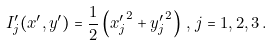<formula> <loc_0><loc_0><loc_500><loc_500>I ^ { \prime } _ { j } ( x ^ { \prime } , y ^ { \prime } ) = \frac { 1 } { 2 } \left ( { x ^ { \prime } _ { j } } ^ { 2 } + { y ^ { \prime } _ { j } } ^ { 2 } \right ) \, , \, j = 1 , 2 , 3 \, .</formula> 